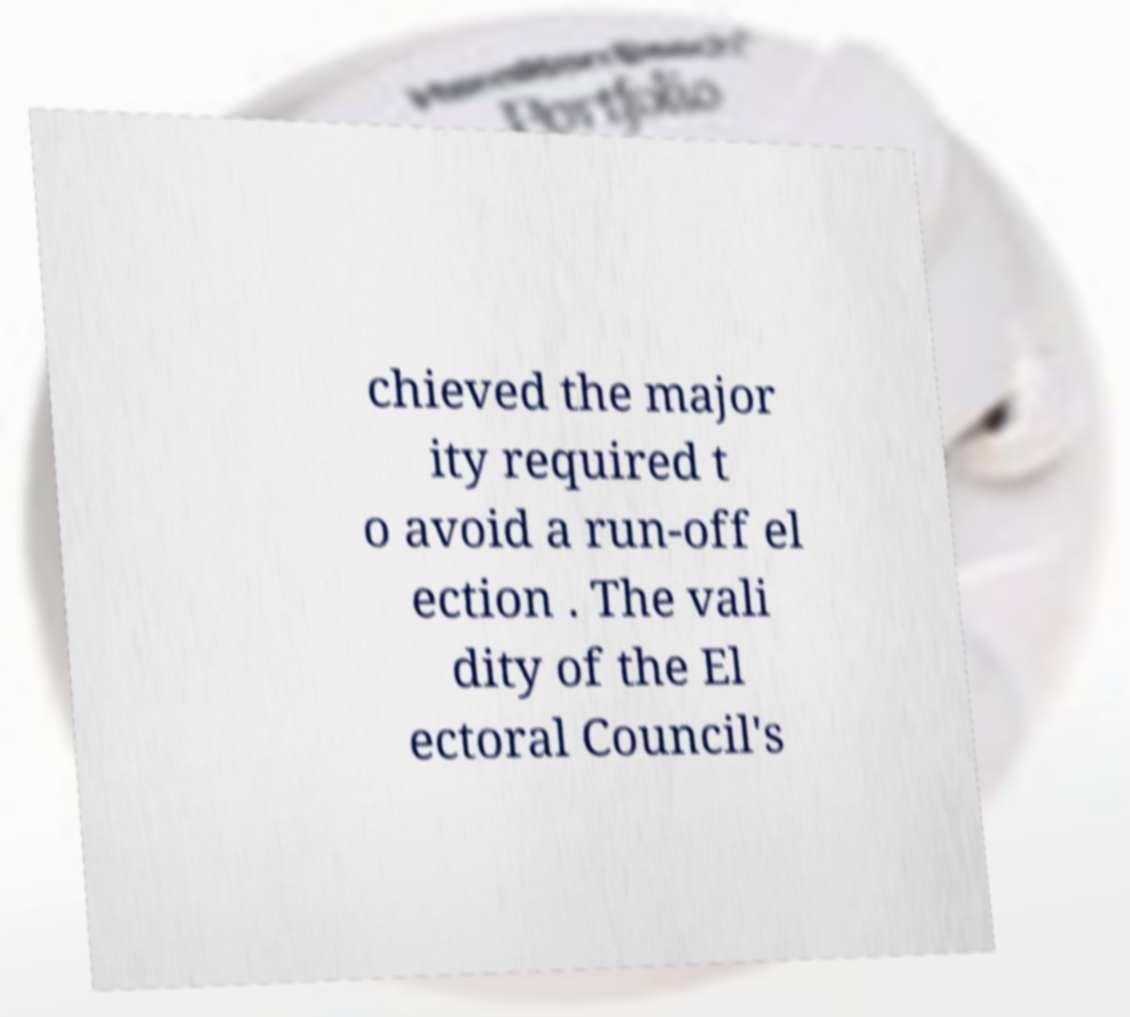I need the written content from this picture converted into text. Can you do that? chieved the major ity required t o avoid a run-off el ection . The vali dity of the El ectoral Council's 